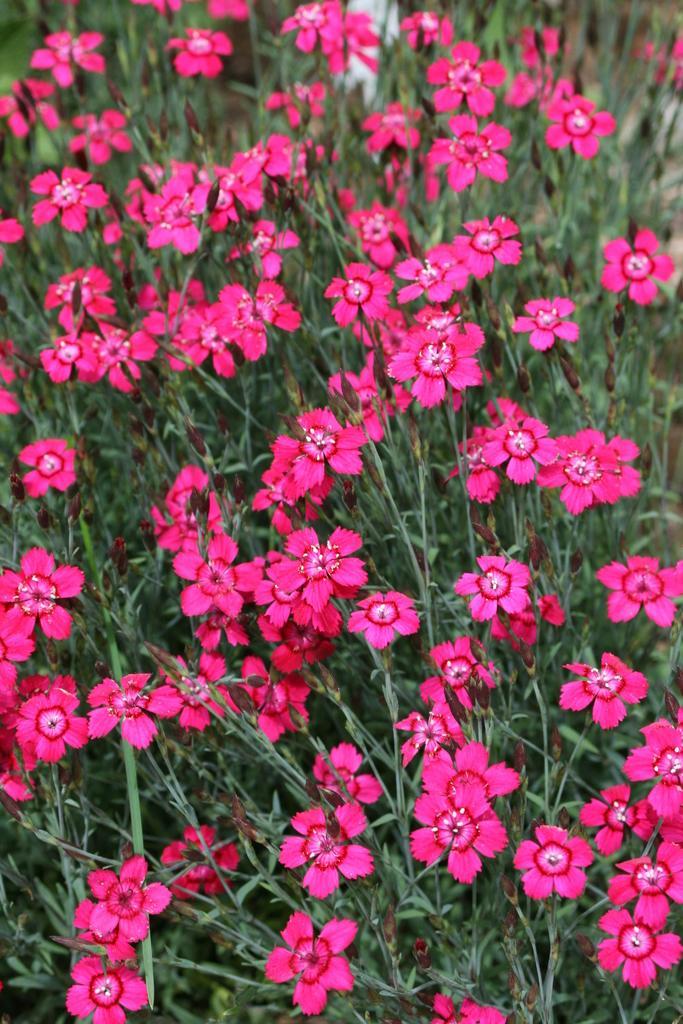Could you give a brief overview of what you see in this image? In this picture we can see the plants and flowers. 